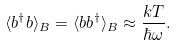Convert formula to latex. <formula><loc_0><loc_0><loc_500><loc_500>\langle { b } ^ { \dagger } { b } \rangle _ { B } = \langle { b b } ^ { \dagger } \rangle _ { B } \approx \frac { k T } { \hbar { \omega } } .</formula> 